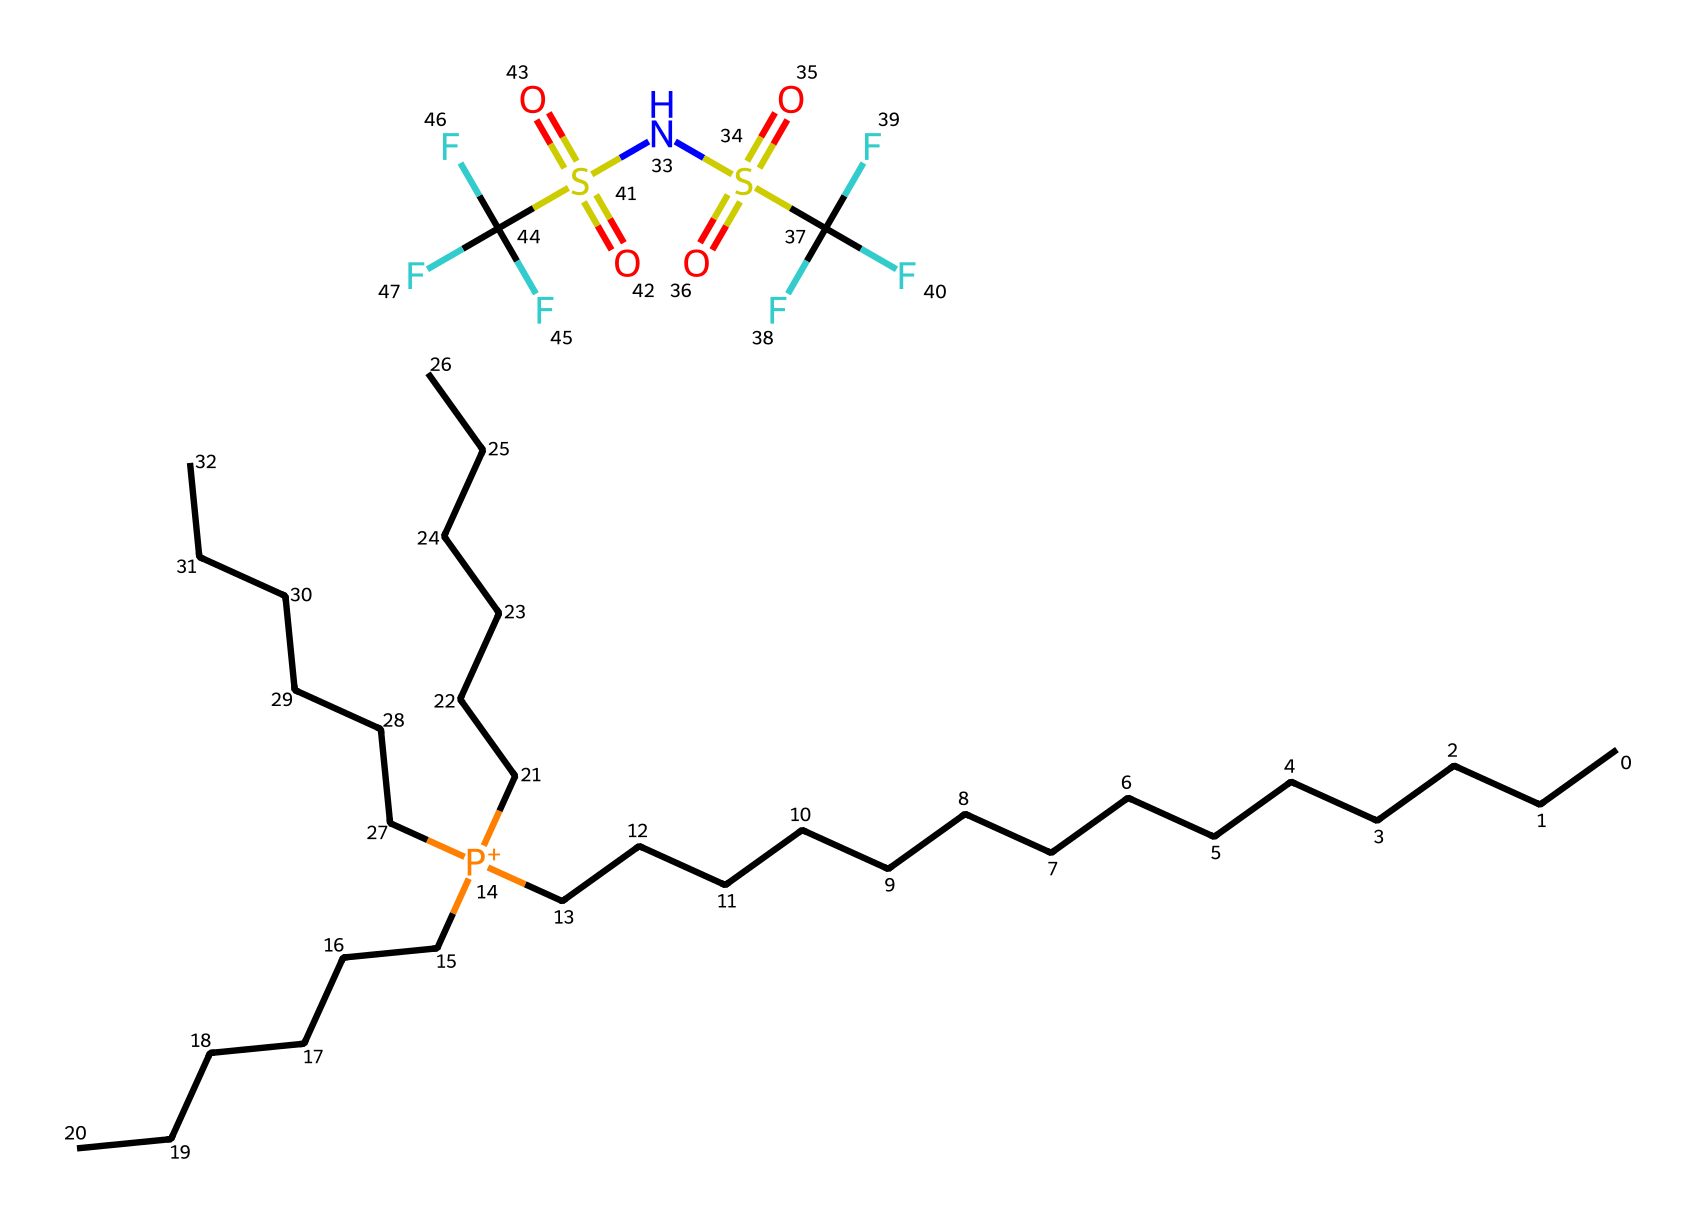What is the total number of carbon atoms in this ionic liquid? By examining the structure, we identify that there are 14 carbon atoms from the tetradecyl groups, and an additional 18 carbon atoms from the trihexyl groups (6 from each of the three alkyl chains). Therefore, the total number is 14 + 18 = 32.
Answer: 32 What is the central cationic species in this ionic liquid? The structure shows a phosphonium ion at the center, indicated by the phosphorus atom and the surrounding alkyl chains providing the cationic character.
Answer: phosphonium How many sulfur atoms are present in the anion? Each sulfonyl group (S(=O)(=O)) in the anion corresponds to one sulfur atom. There are two of these groups, thus there are 2 sulfur atoms in total.
Answer: 2 Is this ionic liquid hydrophobic or hydrophilic? The presence of long hydrophobic alkyl chains and the chemical structure suggests that this ionic liquid is primarily hydrophobic.
Answer: hydrophobic What type of bond connects the phosphorus to the carbon chains? The phosphorus is connected to the carbon chains via covalent bonds, a common feature in organic phosphonium compounds.
Answer: covalent bonds What characteristic suggests this ionic liquid has high thermal stability? The presence of bulky, long-chain alkyl groups typically enhances the thermal stability of ionic liquids due to increased steric hindrance and strong van der Waals interactions.
Answer: bulky alkyl groups 